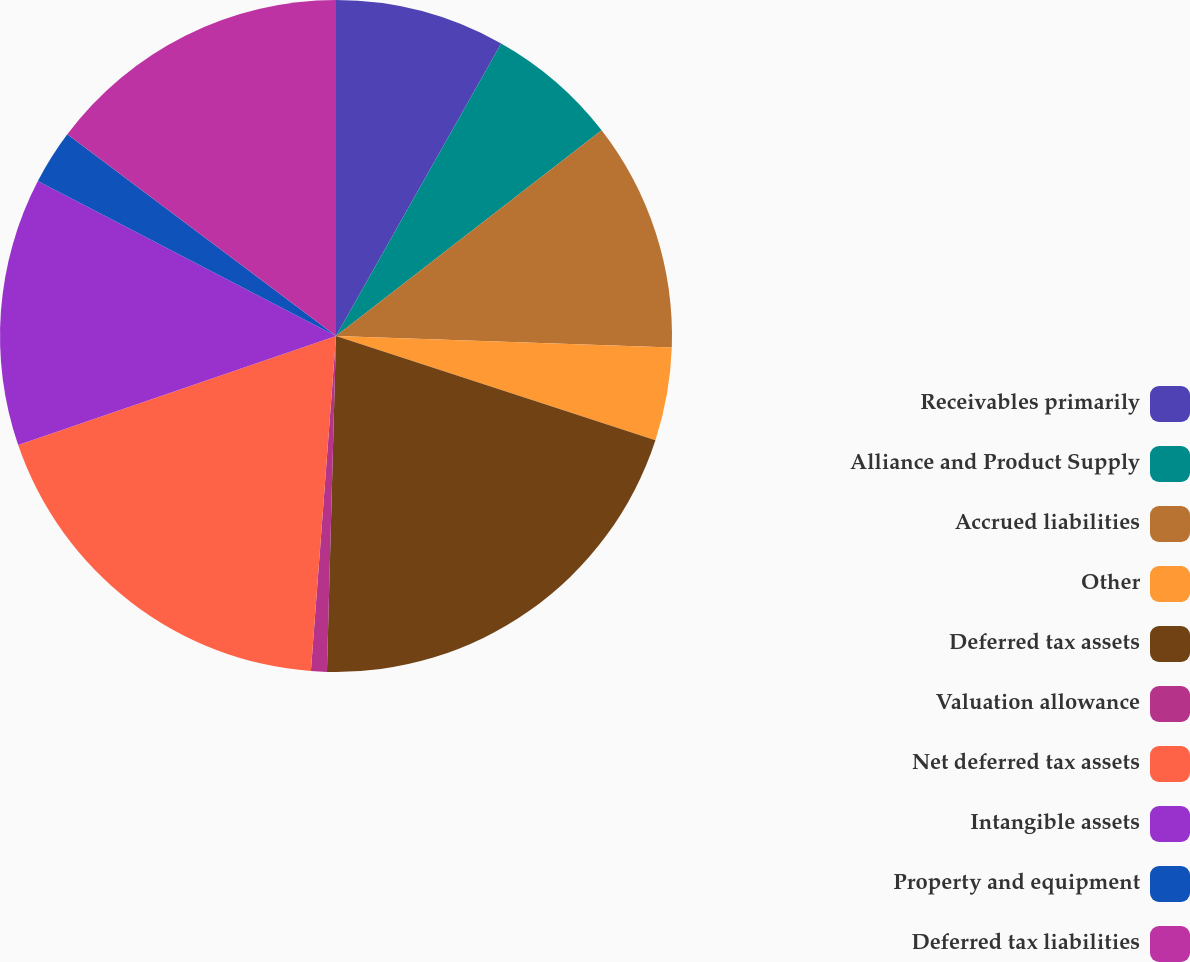Convert chart. <chart><loc_0><loc_0><loc_500><loc_500><pie_chart><fcel>Receivables primarily<fcel>Alliance and Product Supply<fcel>Accrued liabilities<fcel>Other<fcel>Deferred tax assets<fcel>Valuation allowance<fcel>Net deferred tax assets<fcel>Intangible assets<fcel>Property and equipment<fcel>Deferred tax liabilities<nl><fcel>8.18%<fcel>6.33%<fcel>11.04%<fcel>4.47%<fcel>20.41%<fcel>0.76%<fcel>18.55%<fcel>12.89%<fcel>2.62%<fcel>14.75%<nl></chart> 